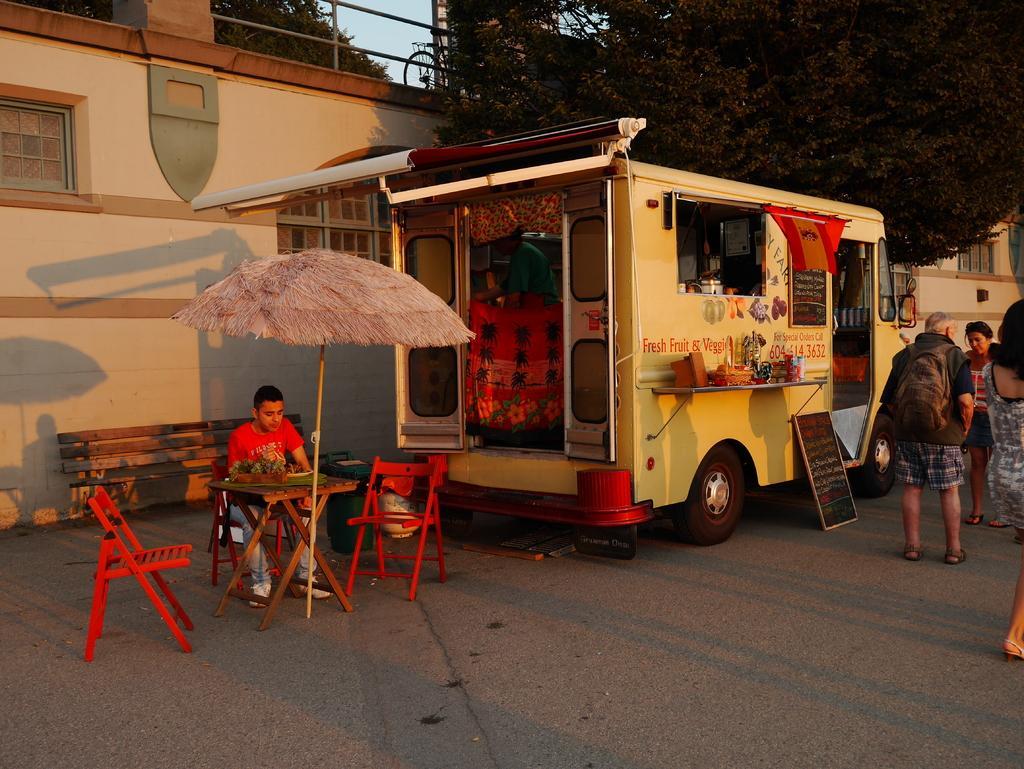Could you give a brief overview of what you see in this image? In the image we can see there is a person who is sitting under the umbrella and there is a food truck and there are people standing on the road and behind there are trees and building. 